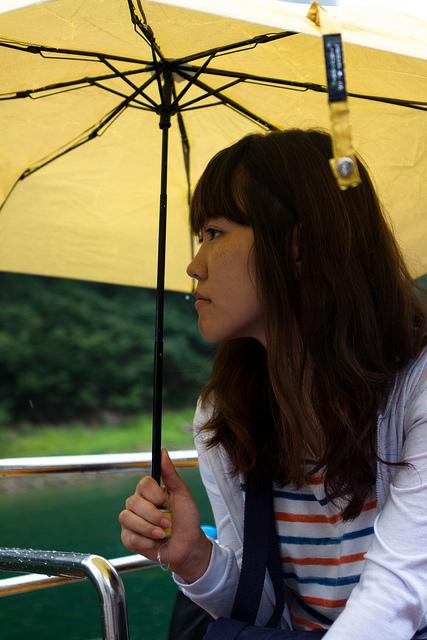What does this person use the umbrella for? rain 